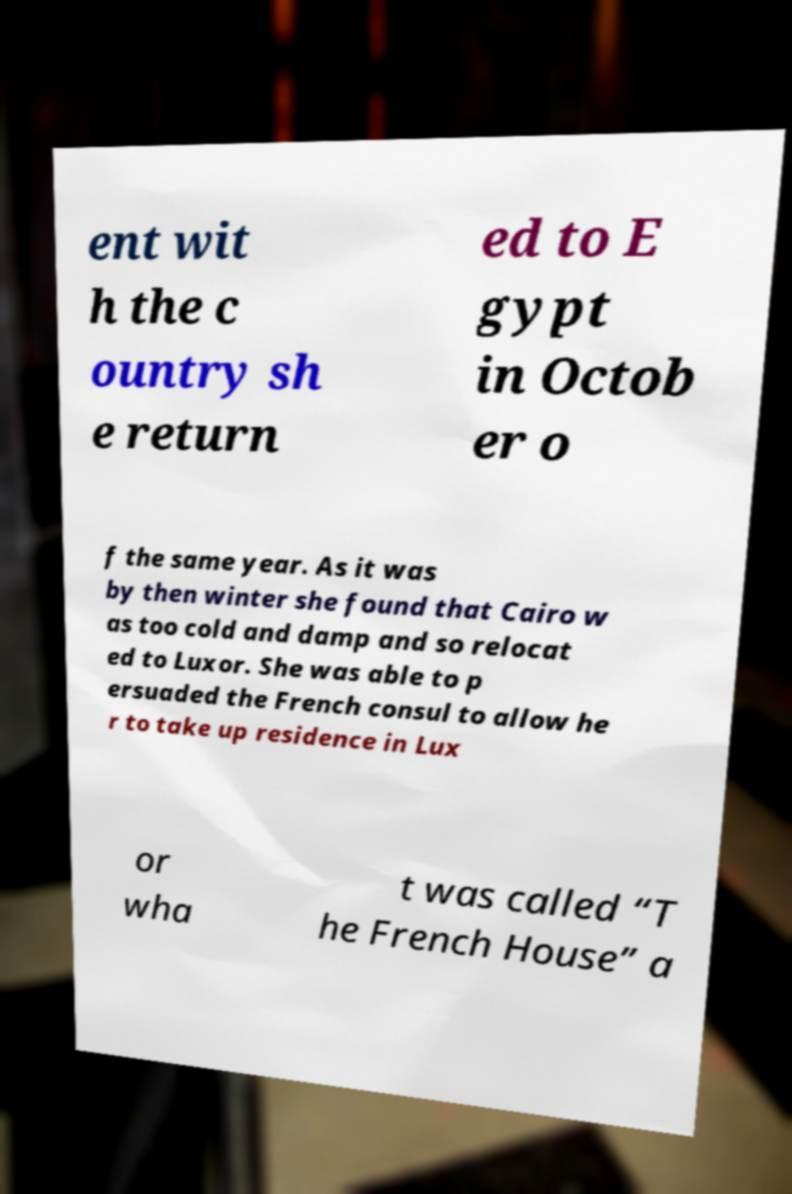I need the written content from this picture converted into text. Can you do that? ent wit h the c ountry sh e return ed to E gypt in Octob er o f the same year. As it was by then winter she found that Cairo w as too cold and damp and so relocat ed to Luxor. She was able to p ersuaded the French consul to allow he r to take up residence in Lux or wha t was called “T he French House” a 